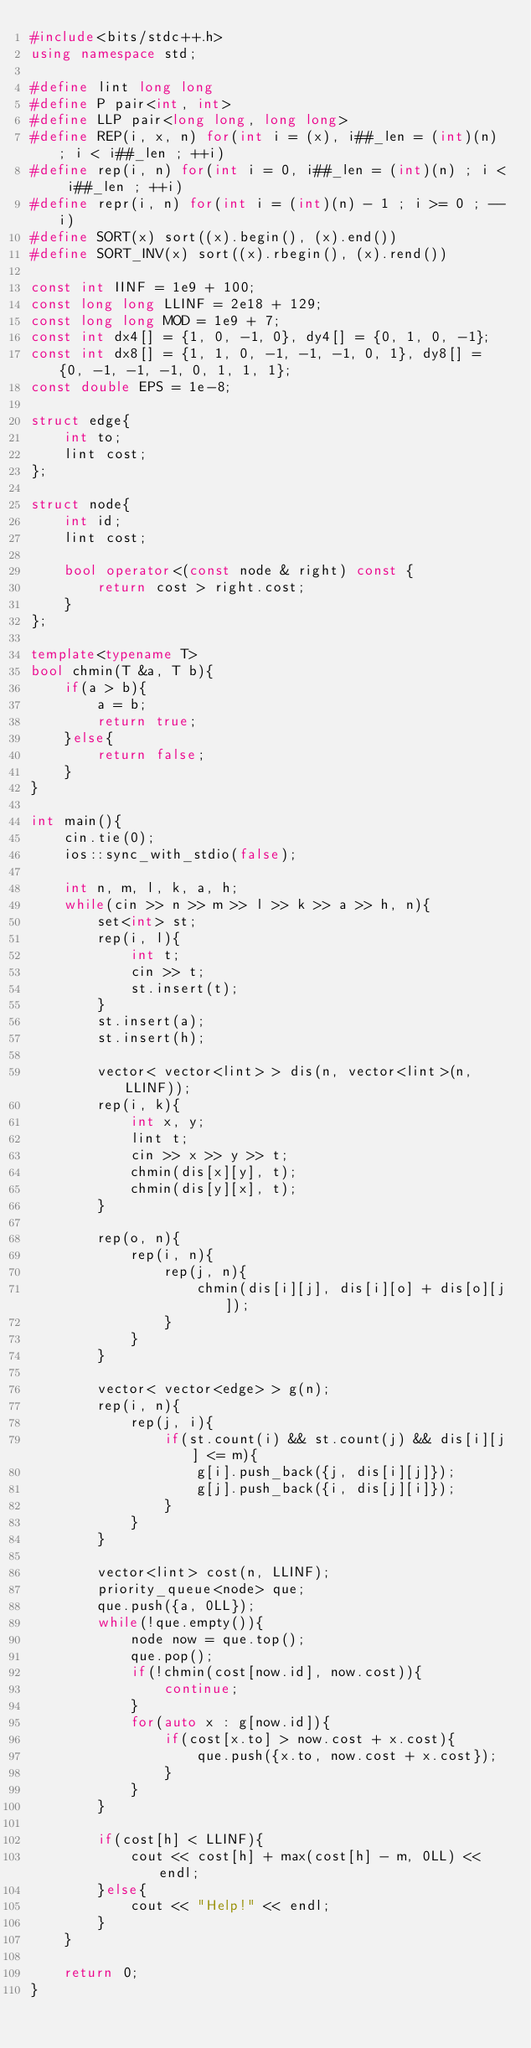Convert code to text. <code><loc_0><loc_0><loc_500><loc_500><_C++_>#include<bits/stdc++.h>
using namespace std;

#define lint long long
#define P pair<int, int>
#define LLP pair<long long, long long>
#define REP(i, x, n) for(int i = (x), i##_len = (int)(n) ; i < i##_len ; ++i)
#define rep(i, n) for(int i = 0, i##_len = (int)(n) ; i < i##_len ; ++i)
#define repr(i, n) for(int i = (int)(n) - 1 ; i >= 0 ; --i)
#define SORT(x) sort((x).begin(), (x).end())
#define SORT_INV(x) sort((x).rbegin(), (x).rend())

const int IINF = 1e9 + 100;
const long long LLINF = 2e18 + 129;
const long long MOD = 1e9 + 7;
const int dx4[] = {1, 0, -1, 0}, dy4[] = {0, 1, 0, -1};
const int dx8[] = {1, 1, 0, -1, -1, -1, 0, 1}, dy8[] = {0, -1, -1, -1, 0, 1, 1, 1};
const double EPS = 1e-8;

struct edge{
    int to;
    lint cost;
};

struct node{
    int id;
    lint cost;

    bool operator<(const node & right) const {
        return cost > right.cost;
    }
};

template<typename T>
bool chmin(T &a, T b){
    if(a > b){
        a = b;
        return true;
    }else{
        return false;
    }
}

int main(){
    cin.tie(0);
    ios::sync_with_stdio(false);

    int n, m, l, k, a, h;
    while(cin >> n >> m >> l >> k >> a >> h, n){
        set<int> st;
        rep(i, l){
            int t;
            cin >> t;
            st.insert(t);
        }
        st.insert(a);
        st.insert(h);

        vector< vector<lint> > dis(n, vector<lint>(n, LLINF));
        rep(i, k){
            int x, y;
            lint t;
            cin >> x >> y >> t;
            chmin(dis[x][y], t);
            chmin(dis[y][x], t);
        }
        
        rep(o, n){
            rep(i, n){
                rep(j, n){
                    chmin(dis[i][j], dis[i][o] + dis[o][j]);
                }
            }
        }

        vector< vector<edge> > g(n);
        rep(i, n){
            rep(j, i){
                if(st.count(i) && st.count(j) && dis[i][j] <= m){
                    g[i].push_back({j, dis[i][j]});
                    g[j].push_back({i, dis[j][i]});
                }
            }
        }

        vector<lint> cost(n, LLINF);
        priority_queue<node> que;
        que.push({a, 0LL});
        while(!que.empty()){
            node now = que.top();
            que.pop();
            if(!chmin(cost[now.id], now.cost)){
                continue;
            }
            for(auto x : g[now.id]){
                if(cost[x.to] > now.cost + x.cost){
                    que.push({x.to, now.cost + x.cost});
                }
            }
        }

        if(cost[h] < LLINF){
            cout << cost[h] + max(cost[h] - m, 0LL) << endl;
        }else{
            cout << "Help!" << endl;
        }
    }

    return 0;
}
</code> 